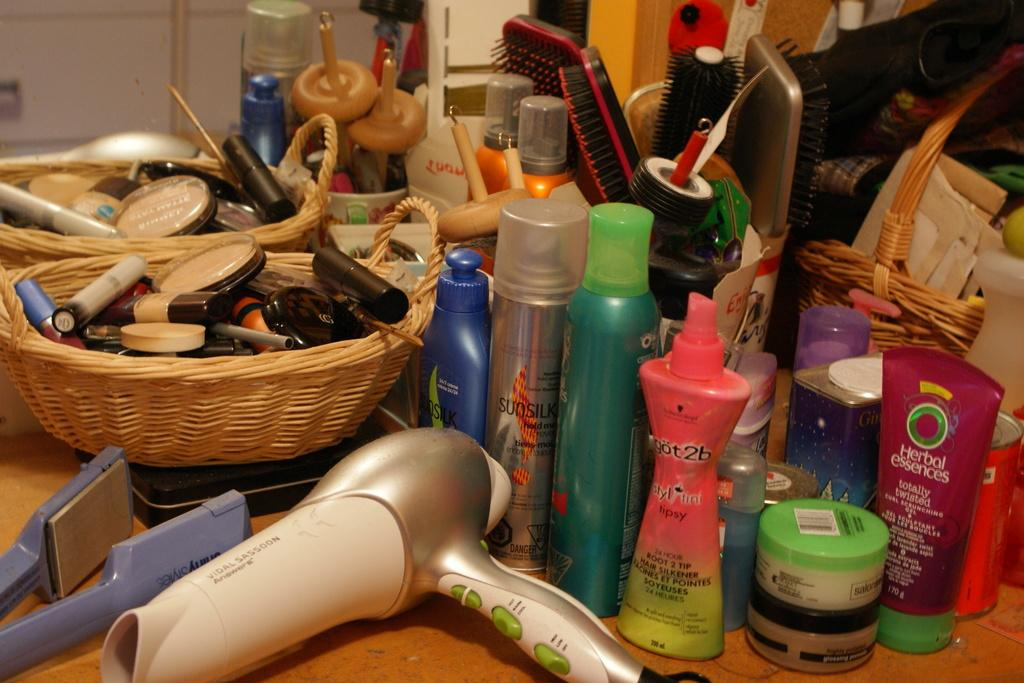Provide a one-sentence caption for the provided image. A messy bathroom counter has a hairdryer and hair products including a pink bottle of got2b spray. 